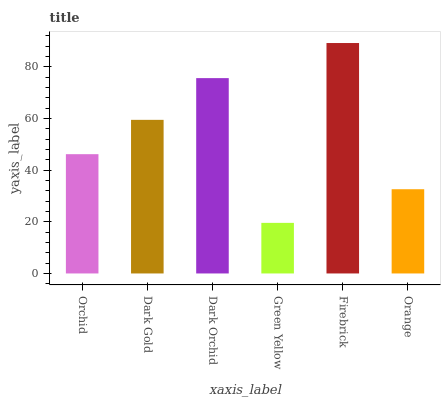Is Green Yellow the minimum?
Answer yes or no. Yes. Is Firebrick the maximum?
Answer yes or no. Yes. Is Dark Gold the minimum?
Answer yes or no. No. Is Dark Gold the maximum?
Answer yes or no. No. Is Dark Gold greater than Orchid?
Answer yes or no. Yes. Is Orchid less than Dark Gold?
Answer yes or no. Yes. Is Orchid greater than Dark Gold?
Answer yes or no. No. Is Dark Gold less than Orchid?
Answer yes or no. No. Is Dark Gold the high median?
Answer yes or no. Yes. Is Orchid the low median?
Answer yes or no. Yes. Is Firebrick the high median?
Answer yes or no. No. Is Dark Gold the low median?
Answer yes or no. No. 